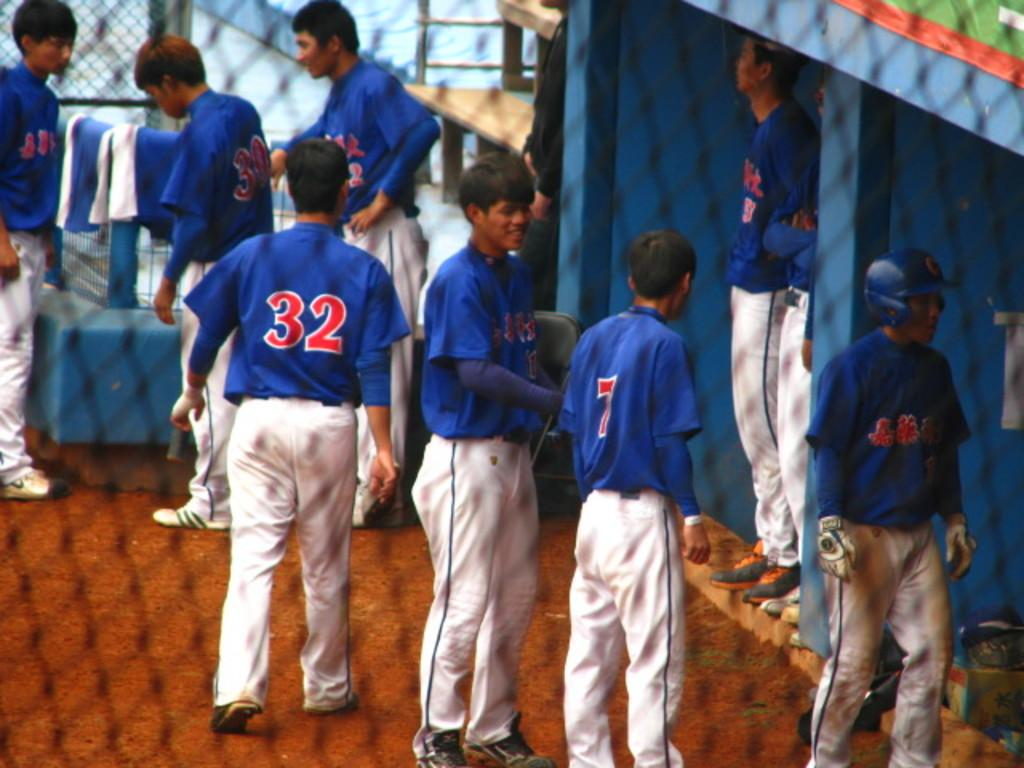<image>
Summarize the visual content of the image. Players number 7 and 32 among others standing in the dugout. 